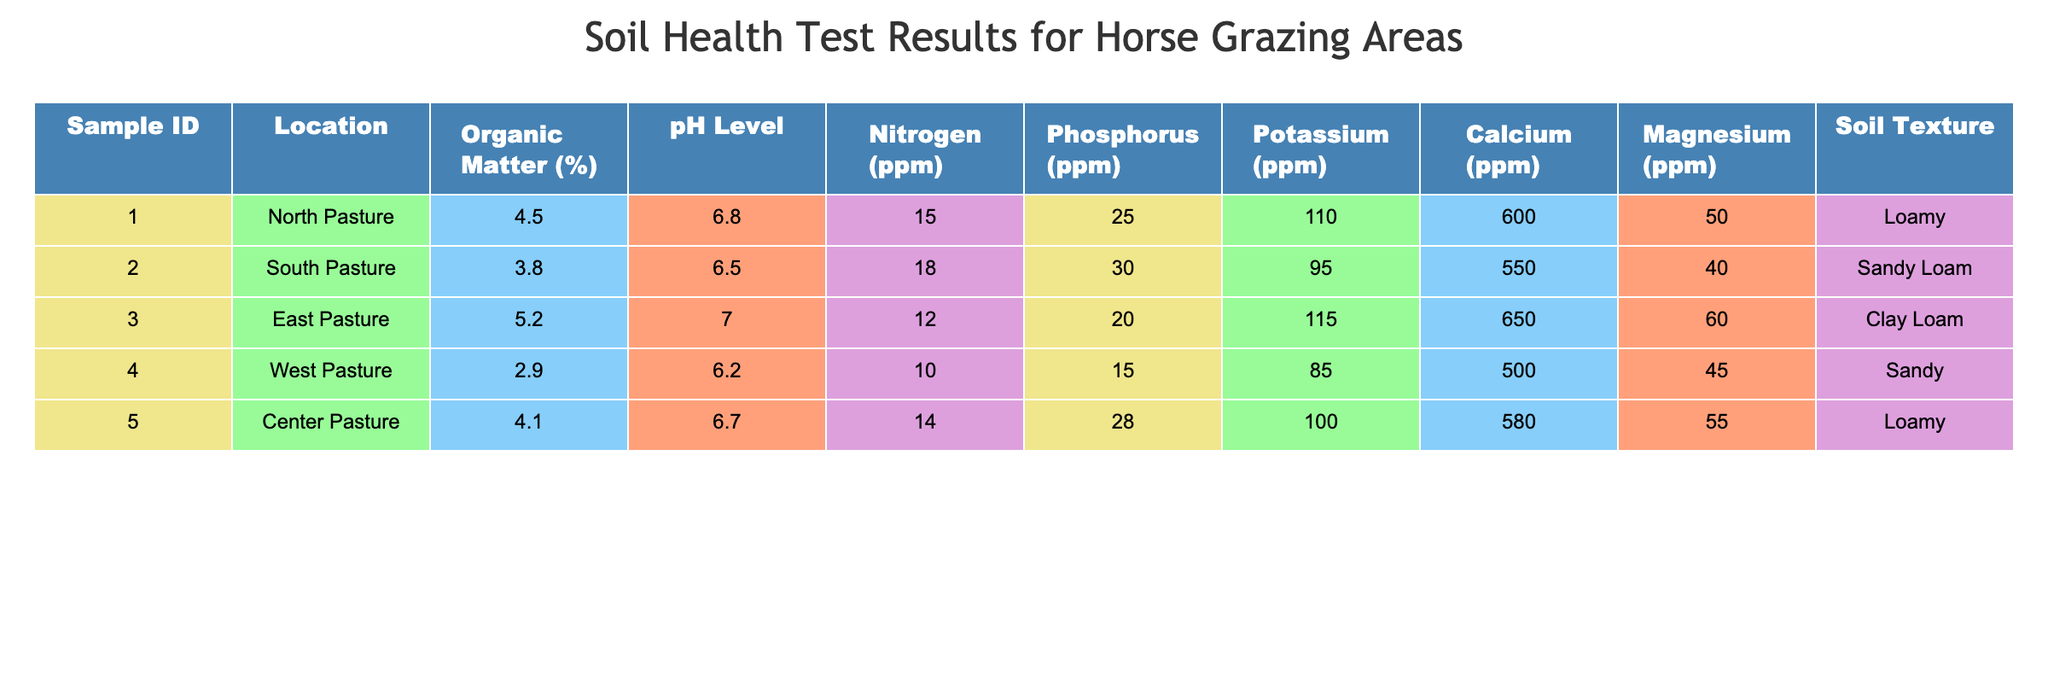What is the pH level of the East Pasture? The pH level for the East Pasture can be found in the table under the corresponding location, which shows a value of 7.0.
Answer: 7.0 Which pasture has the highest organic matter percentage? By reviewing the organic matter percentage column, we can see that the East Pasture has the highest value of 5.2%.
Answer: East Pasture Calculate the average nitrogen level across all pastures. To find the average nitrogen level, we total the values: 15 + 18 + 12 + 10 + 14 = 69. Then we divide by the number of samples (5): 69 / 5 = 13.8.
Answer: 13.8 Is the potassium level in the Center Pasture higher than in the South Pasture? The potassium level for the Center Pasture is 100 ppm and for the South Pasture is 95 ppm. Since 100 is greater than 95, the statement is true.
Answer: Yes How much more calcium is present in the East Pasture compared to the West Pasture? The calcium level in the East Pasture is 650 ppm and in the West Pasture is 500 ppm. The difference is 650 - 500 = 150 ppm.
Answer: 150 ppm Which pasture has the lowest pH level? Looking at the pH level column, the West Pasture has the lowest pH level at 6.2.
Answer: West Pasture Is there a pasture with a magnesium level of 50 ppm? Checking the magnesium levels for each pasture, the North Pasture has a magnesium level of 50 ppm. Thus, the statement is true.
Answer: Yes What is the total phosphorus level for the North and Center Pastures combined? The phosphorus levels are 25 ppm for the North Pasture and 28 ppm for the Center Pasture. Adding these values gives us 25 + 28 = 53 ppm.
Answer: 53 ppm Which soil texture appears most frequently in the table? Analyzing the soil texture column, the Loamy texture appears twice (in North and Center Pasture), while other textures appear only once.
Answer: Loamy 